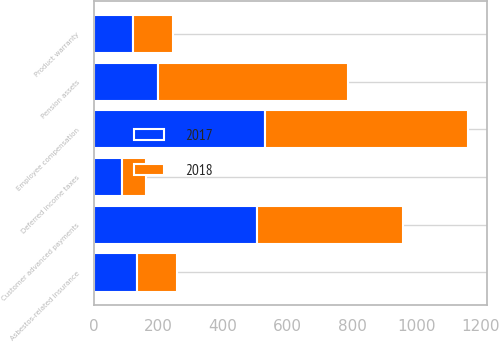Convert chart to OTSL. <chart><loc_0><loc_0><loc_500><loc_500><stacked_bar_chart><ecel><fcel>Pension assets<fcel>Asbestos-related insurance<fcel>Deferred income taxes<fcel>Employee compensation<fcel>Customer advanced payments<fcel>Product warranty<nl><fcel>2017<fcel>197<fcel>133<fcel>86<fcel>531<fcel>505<fcel>120<nl><fcel>2018<fcel>591<fcel>124<fcel>74<fcel>629<fcel>453<fcel>124<nl></chart> 